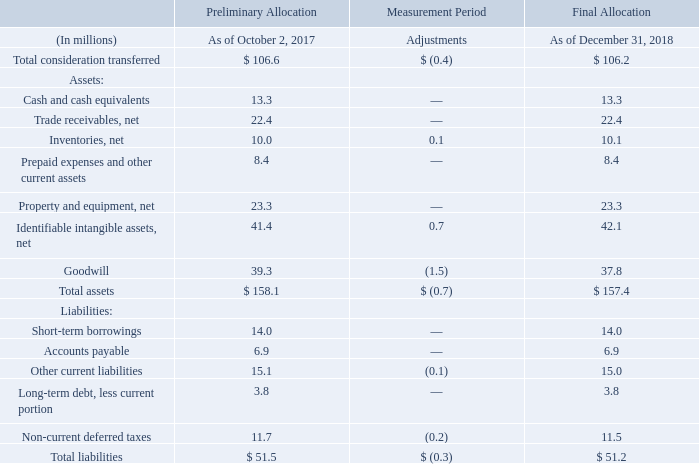Acquisition of Fagerdala
On October 2, 2017, the Company acquired Fagerdala Singapore Pte Ltd., a manufacturer and fabricator of polyethylene foam based in Singapore, to join its Product Care division. We acquired 100% of Fagerdala shares for estimated consideration of S$144.7 million, or $106.2 million, net of cash acquired of $13.3 million, inclusive of purchase price adjustments which were finalized in the third quarter of 2018. We acquired Fagerdala to leverage its manufacturing footprint in Asia, experience in foam manufacturing and fabrication and commercial organization to expand our presence across multiple industries utilizing fulfillment to distribute goods.
The following table summarizes the consideration transferred to acquire Fagerdala and the final allocation of the purchase price among the assets acquired and liabilities assumed. price among the assets acquired and liabilities assumed.
What was the company acquired in 2017? Fagerdala singapore pte ltd. Why was the company acquired in 2017? To leverage its manufacturing footprint in asia, experience in foam manufacturing and fabrication and commercial organization to expand our presence across multiple industries utilizing fulfillment to distribute goods. What does the table represent? Summarizes the consideration transferred to acquire fagerdala and the final allocation of the purchase price among the assets acquired and liabilities assumed. price among the assets acquired and liabilities assumed. What is the value of 1 USD to SGD at time of calculation? 144.7/106.2
Answer: 1.36. What is the asset to liability ratio As of December 31, 2018? 
Answer scale should be: percent. 51.2/157.4
Answer: 32.53. What is the difference between the asset to liability ratio As of December 31, 2018 vs. As of October 2, 2017?
Answer scale should be: percent. (51.2/157.4)-(51.5/158.1)
Answer: -0.05. 